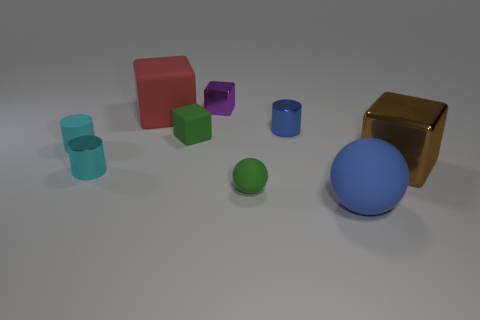What color is the large matte sphere?
Offer a very short reply. Blue. Are there fewer tiny blue objects that are in front of the small cyan metallic object than cyan rubber cylinders?
Make the answer very short. Yes. Is there any other thing that has the same shape as the brown thing?
Give a very brief answer. Yes. Are any cylinders visible?
Provide a succinct answer. Yes. Are there fewer blue shiny objects than small blue metal cubes?
Provide a succinct answer. No. What number of red blocks have the same material as the blue cylinder?
Offer a very short reply. 0. There is a big cube that is made of the same material as the purple thing; what is its color?
Offer a terse response. Brown. The large brown thing is what shape?
Keep it short and to the point. Cube. How many big matte cubes have the same color as the large ball?
Provide a succinct answer. 0. There is a cyan matte object that is the same size as the purple block; what is its shape?
Make the answer very short. Cylinder. 